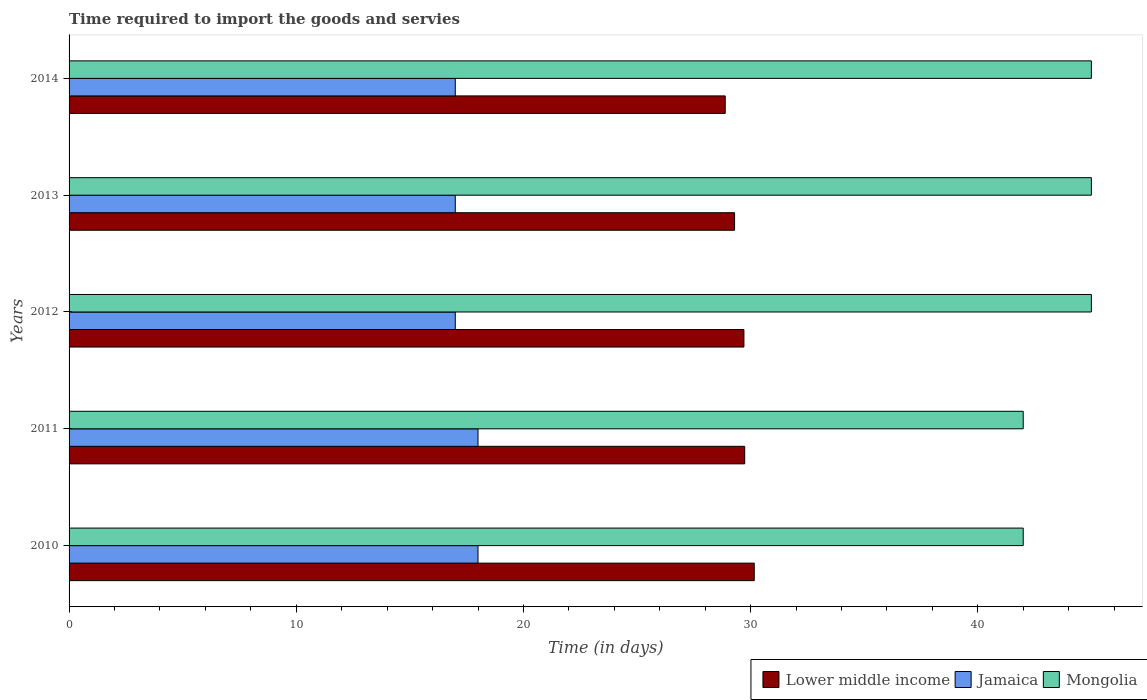How many different coloured bars are there?
Your response must be concise. 3. How many groups of bars are there?
Provide a succinct answer. 5. Are the number of bars on each tick of the Y-axis equal?
Make the answer very short. Yes. What is the label of the 3rd group of bars from the top?
Your answer should be compact. 2012. In how many cases, is the number of bars for a given year not equal to the number of legend labels?
Give a very brief answer. 0. What is the number of days required to import the goods and services in Lower middle income in 2012?
Your response must be concise. 29.71. Across all years, what is the maximum number of days required to import the goods and services in Mongolia?
Provide a short and direct response. 45. Across all years, what is the minimum number of days required to import the goods and services in Lower middle income?
Your response must be concise. 28.88. In which year was the number of days required to import the goods and services in Jamaica maximum?
Provide a succinct answer. 2010. What is the total number of days required to import the goods and services in Lower middle income in the graph?
Offer a very short reply. 147.78. What is the difference between the number of days required to import the goods and services in Jamaica in 2011 and that in 2013?
Offer a terse response. 1. What is the difference between the number of days required to import the goods and services in Lower middle income in 2014 and the number of days required to import the goods and services in Jamaica in 2012?
Ensure brevity in your answer.  11.88. What is the average number of days required to import the goods and services in Mongolia per year?
Offer a very short reply. 43.8. In the year 2014, what is the difference between the number of days required to import the goods and services in Mongolia and number of days required to import the goods and services in Jamaica?
Your answer should be very brief. 28. In how many years, is the number of days required to import the goods and services in Mongolia greater than 20 days?
Provide a short and direct response. 5. What is the ratio of the number of days required to import the goods and services in Jamaica in 2013 to that in 2014?
Your answer should be very brief. 1. Is the number of days required to import the goods and services in Mongolia in 2010 less than that in 2012?
Give a very brief answer. Yes. What is the difference between the highest and the second highest number of days required to import the goods and services in Lower middle income?
Offer a terse response. 0.42. What is the difference between the highest and the lowest number of days required to import the goods and services in Mongolia?
Keep it short and to the point. 3. What does the 1st bar from the top in 2011 represents?
Your answer should be compact. Mongolia. What does the 2nd bar from the bottom in 2014 represents?
Make the answer very short. Jamaica. How many bars are there?
Offer a terse response. 15. What is the difference between two consecutive major ticks on the X-axis?
Your response must be concise. 10. Does the graph contain grids?
Your answer should be compact. No. Where does the legend appear in the graph?
Your response must be concise. Bottom right. How many legend labels are there?
Keep it short and to the point. 3. What is the title of the graph?
Your answer should be compact. Time required to import the goods and servies. Does "Cyprus" appear as one of the legend labels in the graph?
Ensure brevity in your answer.  No. What is the label or title of the X-axis?
Provide a succinct answer. Time (in days). What is the label or title of the Y-axis?
Your answer should be compact. Years. What is the Time (in days) of Lower middle income in 2010?
Keep it short and to the point. 30.16. What is the Time (in days) in Jamaica in 2010?
Provide a succinct answer. 18. What is the Time (in days) of Mongolia in 2010?
Offer a very short reply. 42. What is the Time (in days) of Lower middle income in 2011?
Provide a succinct answer. 29.74. What is the Time (in days) of Mongolia in 2011?
Keep it short and to the point. 42. What is the Time (in days) in Lower middle income in 2012?
Keep it short and to the point. 29.71. What is the Time (in days) of Lower middle income in 2013?
Offer a very short reply. 29.29. What is the Time (in days) in Jamaica in 2013?
Provide a succinct answer. 17. What is the Time (in days) of Mongolia in 2013?
Your response must be concise. 45. What is the Time (in days) of Lower middle income in 2014?
Offer a terse response. 28.88. What is the Time (in days) of Mongolia in 2014?
Your answer should be very brief. 45. Across all years, what is the maximum Time (in days) of Lower middle income?
Make the answer very short. 30.16. Across all years, what is the maximum Time (in days) of Jamaica?
Ensure brevity in your answer.  18. Across all years, what is the minimum Time (in days) of Lower middle income?
Give a very brief answer. 28.88. What is the total Time (in days) of Lower middle income in the graph?
Your answer should be compact. 147.78. What is the total Time (in days) of Mongolia in the graph?
Your response must be concise. 219. What is the difference between the Time (in days) of Lower middle income in 2010 and that in 2011?
Provide a succinct answer. 0.42. What is the difference between the Time (in days) in Mongolia in 2010 and that in 2011?
Ensure brevity in your answer.  0. What is the difference between the Time (in days) of Lower middle income in 2010 and that in 2012?
Offer a very short reply. 0.45. What is the difference between the Time (in days) in Jamaica in 2010 and that in 2012?
Provide a succinct answer. 1. What is the difference between the Time (in days) of Mongolia in 2010 and that in 2012?
Make the answer very short. -3. What is the difference between the Time (in days) in Lower middle income in 2010 and that in 2013?
Ensure brevity in your answer.  0.87. What is the difference between the Time (in days) of Lower middle income in 2010 and that in 2014?
Your answer should be compact. 1.28. What is the difference between the Time (in days) of Jamaica in 2010 and that in 2014?
Ensure brevity in your answer.  1. What is the difference between the Time (in days) of Lower middle income in 2011 and that in 2012?
Your answer should be compact. 0.03. What is the difference between the Time (in days) in Mongolia in 2011 and that in 2012?
Offer a very short reply. -3. What is the difference between the Time (in days) in Lower middle income in 2011 and that in 2013?
Make the answer very short. 0.45. What is the difference between the Time (in days) in Lower middle income in 2011 and that in 2014?
Your answer should be very brief. 0.86. What is the difference between the Time (in days) in Jamaica in 2011 and that in 2014?
Your response must be concise. 1. What is the difference between the Time (in days) of Lower middle income in 2012 and that in 2013?
Your answer should be compact. 0.41. What is the difference between the Time (in days) of Jamaica in 2012 and that in 2013?
Ensure brevity in your answer.  0. What is the difference between the Time (in days) of Mongolia in 2012 and that in 2013?
Keep it short and to the point. 0. What is the difference between the Time (in days) in Lower middle income in 2012 and that in 2014?
Your answer should be compact. 0.82. What is the difference between the Time (in days) of Jamaica in 2012 and that in 2014?
Offer a very short reply. 0. What is the difference between the Time (in days) in Mongolia in 2012 and that in 2014?
Make the answer very short. 0. What is the difference between the Time (in days) of Lower middle income in 2013 and that in 2014?
Offer a very short reply. 0.41. What is the difference between the Time (in days) of Jamaica in 2013 and that in 2014?
Provide a short and direct response. 0. What is the difference between the Time (in days) in Mongolia in 2013 and that in 2014?
Offer a very short reply. 0. What is the difference between the Time (in days) of Lower middle income in 2010 and the Time (in days) of Jamaica in 2011?
Offer a very short reply. 12.16. What is the difference between the Time (in days) in Lower middle income in 2010 and the Time (in days) in Mongolia in 2011?
Offer a terse response. -11.84. What is the difference between the Time (in days) in Lower middle income in 2010 and the Time (in days) in Jamaica in 2012?
Offer a very short reply. 13.16. What is the difference between the Time (in days) of Lower middle income in 2010 and the Time (in days) of Mongolia in 2012?
Keep it short and to the point. -14.84. What is the difference between the Time (in days) in Lower middle income in 2010 and the Time (in days) in Jamaica in 2013?
Keep it short and to the point. 13.16. What is the difference between the Time (in days) in Lower middle income in 2010 and the Time (in days) in Mongolia in 2013?
Provide a short and direct response. -14.84. What is the difference between the Time (in days) of Jamaica in 2010 and the Time (in days) of Mongolia in 2013?
Provide a succinct answer. -27. What is the difference between the Time (in days) in Lower middle income in 2010 and the Time (in days) in Jamaica in 2014?
Offer a terse response. 13.16. What is the difference between the Time (in days) in Lower middle income in 2010 and the Time (in days) in Mongolia in 2014?
Offer a very short reply. -14.84. What is the difference between the Time (in days) of Jamaica in 2010 and the Time (in days) of Mongolia in 2014?
Keep it short and to the point. -27. What is the difference between the Time (in days) in Lower middle income in 2011 and the Time (in days) in Jamaica in 2012?
Provide a short and direct response. 12.74. What is the difference between the Time (in days) of Lower middle income in 2011 and the Time (in days) of Mongolia in 2012?
Provide a succinct answer. -15.26. What is the difference between the Time (in days) in Lower middle income in 2011 and the Time (in days) in Jamaica in 2013?
Your answer should be compact. 12.74. What is the difference between the Time (in days) of Lower middle income in 2011 and the Time (in days) of Mongolia in 2013?
Provide a succinct answer. -15.26. What is the difference between the Time (in days) of Jamaica in 2011 and the Time (in days) of Mongolia in 2013?
Ensure brevity in your answer.  -27. What is the difference between the Time (in days) of Lower middle income in 2011 and the Time (in days) of Jamaica in 2014?
Make the answer very short. 12.74. What is the difference between the Time (in days) in Lower middle income in 2011 and the Time (in days) in Mongolia in 2014?
Make the answer very short. -15.26. What is the difference between the Time (in days) in Lower middle income in 2012 and the Time (in days) in Jamaica in 2013?
Give a very brief answer. 12.71. What is the difference between the Time (in days) in Lower middle income in 2012 and the Time (in days) in Mongolia in 2013?
Offer a very short reply. -15.29. What is the difference between the Time (in days) in Jamaica in 2012 and the Time (in days) in Mongolia in 2013?
Give a very brief answer. -28. What is the difference between the Time (in days) of Lower middle income in 2012 and the Time (in days) of Jamaica in 2014?
Keep it short and to the point. 12.71. What is the difference between the Time (in days) in Lower middle income in 2012 and the Time (in days) in Mongolia in 2014?
Offer a terse response. -15.29. What is the difference between the Time (in days) in Jamaica in 2012 and the Time (in days) in Mongolia in 2014?
Your answer should be compact. -28. What is the difference between the Time (in days) of Lower middle income in 2013 and the Time (in days) of Jamaica in 2014?
Ensure brevity in your answer.  12.29. What is the difference between the Time (in days) in Lower middle income in 2013 and the Time (in days) in Mongolia in 2014?
Your response must be concise. -15.71. What is the difference between the Time (in days) of Jamaica in 2013 and the Time (in days) of Mongolia in 2014?
Your answer should be very brief. -28. What is the average Time (in days) in Lower middle income per year?
Your answer should be compact. 29.56. What is the average Time (in days) of Jamaica per year?
Your response must be concise. 17.4. What is the average Time (in days) of Mongolia per year?
Provide a succinct answer. 43.8. In the year 2010, what is the difference between the Time (in days) of Lower middle income and Time (in days) of Jamaica?
Provide a short and direct response. 12.16. In the year 2010, what is the difference between the Time (in days) of Lower middle income and Time (in days) of Mongolia?
Your answer should be very brief. -11.84. In the year 2011, what is the difference between the Time (in days) in Lower middle income and Time (in days) in Jamaica?
Offer a very short reply. 11.74. In the year 2011, what is the difference between the Time (in days) in Lower middle income and Time (in days) in Mongolia?
Give a very brief answer. -12.26. In the year 2012, what is the difference between the Time (in days) of Lower middle income and Time (in days) of Jamaica?
Ensure brevity in your answer.  12.71. In the year 2012, what is the difference between the Time (in days) in Lower middle income and Time (in days) in Mongolia?
Your response must be concise. -15.29. In the year 2012, what is the difference between the Time (in days) in Jamaica and Time (in days) in Mongolia?
Keep it short and to the point. -28. In the year 2013, what is the difference between the Time (in days) of Lower middle income and Time (in days) of Jamaica?
Keep it short and to the point. 12.29. In the year 2013, what is the difference between the Time (in days) of Lower middle income and Time (in days) of Mongolia?
Make the answer very short. -15.71. In the year 2014, what is the difference between the Time (in days) in Lower middle income and Time (in days) in Jamaica?
Keep it short and to the point. 11.88. In the year 2014, what is the difference between the Time (in days) of Lower middle income and Time (in days) of Mongolia?
Ensure brevity in your answer.  -16.12. What is the ratio of the Time (in days) in Lower middle income in 2010 to that in 2011?
Your answer should be very brief. 1.01. What is the ratio of the Time (in days) in Jamaica in 2010 to that in 2011?
Give a very brief answer. 1. What is the ratio of the Time (in days) in Lower middle income in 2010 to that in 2012?
Provide a succinct answer. 1.02. What is the ratio of the Time (in days) of Jamaica in 2010 to that in 2012?
Provide a short and direct response. 1.06. What is the ratio of the Time (in days) of Lower middle income in 2010 to that in 2013?
Give a very brief answer. 1.03. What is the ratio of the Time (in days) of Jamaica in 2010 to that in 2013?
Your response must be concise. 1.06. What is the ratio of the Time (in days) in Mongolia in 2010 to that in 2013?
Your response must be concise. 0.93. What is the ratio of the Time (in days) of Lower middle income in 2010 to that in 2014?
Your answer should be compact. 1.04. What is the ratio of the Time (in days) of Jamaica in 2010 to that in 2014?
Provide a short and direct response. 1.06. What is the ratio of the Time (in days) in Jamaica in 2011 to that in 2012?
Ensure brevity in your answer.  1.06. What is the ratio of the Time (in days) in Mongolia in 2011 to that in 2012?
Your answer should be compact. 0.93. What is the ratio of the Time (in days) of Lower middle income in 2011 to that in 2013?
Your answer should be very brief. 1.02. What is the ratio of the Time (in days) in Jamaica in 2011 to that in 2013?
Offer a terse response. 1.06. What is the ratio of the Time (in days) in Mongolia in 2011 to that in 2013?
Your answer should be compact. 0.93. What is the ratio of the Time (in days) in Lower middle income in 2011 to that in 2014?
Offer a very short reply. 1.03. What is the ratio of the Time (in days) in Jamaica in 2011 to that in 2014?
Ensure brevity in your answer.  1.06. What is the ratio of the Time (in days) of Lower middle income in 2012 to that in 2013?
Your response must be concise. 1.01. What is the ratio of the Time (in days) of Jamaica in 2012 to that in 2013?
Provide a short and direct response. 1. What is the ratio of the Time (in days) of Mongolia in 2012 to that in 2013?
Give a very brief answer. 1. What is the ratio of the Time (in days) in Lower middle income in 2012 to that in 2014?
Offer a terse response. 1.03. What is the ratio of the Time (in days) in Jamaica in 2012 to that in 2014?
Offer a terse response. 1. What is the ratio of the Time (in days) of Lower middle income in 2013 to that in 2014?
Make the answer very short. 1.01. What is the ratio of the Time (in days) of Jamaica in 2013 to that in 2014?
Your answer should be compact. 1. What is the ratio of the Time (in days) in Mongolia in 2013 to that in 2014?
Provide a short and direct response. 1. What is the difference between the highest and the second highest Time (in days) in Lower middle income?
Keep it short and to the point. 0.42. What is the difference between the highest and the second highest Time (in days) in Jamaica?
Provide a succinct answer. 0. What is the difference between the highest and the second highest Time (in days) of Mongolia?
Make the answer very short. 0. What is the difference between the highest and the lowest Time (in days) in Lower middle income?
Ensure brevity in your answer.  1.28. 